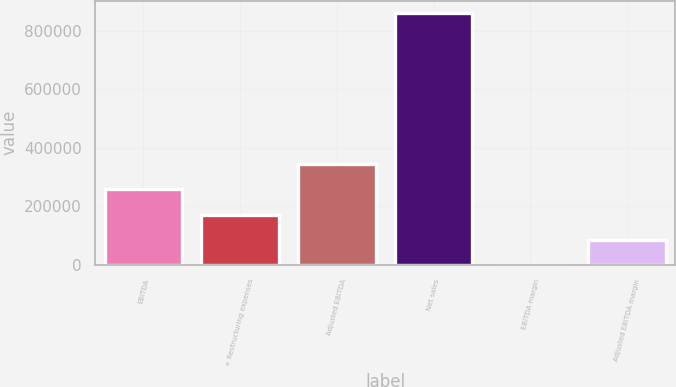<chart> <loc_0><loc_0><loc_500><loc_500><bar_chart><fcel>EBITDA<fcel>+ Restructuring expenses<fcel>Adjusted EBITDA<fcel>Net sales<fcel>EBITDA margin<fcel>Adjusted EBITDA margin<nl><fcel>258257<fcel>172180<fcel>344333<fcel>860792<fcel>27.1<fcel>86103.6<nl></chart> 